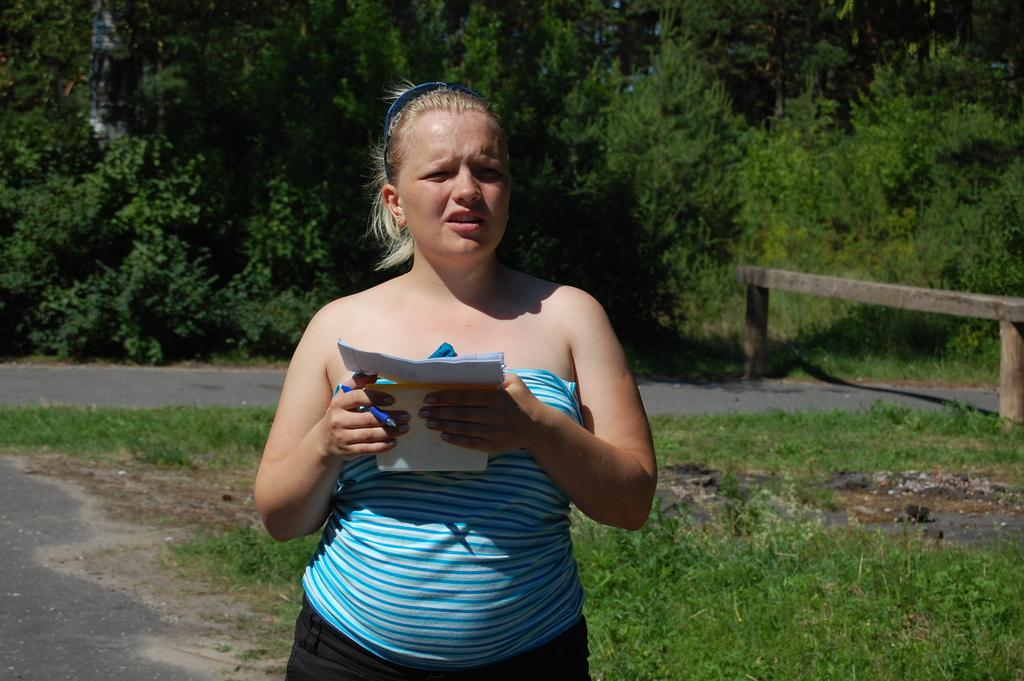Who is present in the image? There is a woman in the image. What is the woman doing in the image? The woman is standing and holding papers and a pen. What is visible at the bottom of the image? There is grass at the bottom of the image. What can be seen in the background of the image? There are trees in the background of the image. What type of books can be seen in the woman's territory in the image? There are no books present in the image, and the concept of territory does not apply to the woman in the image. 